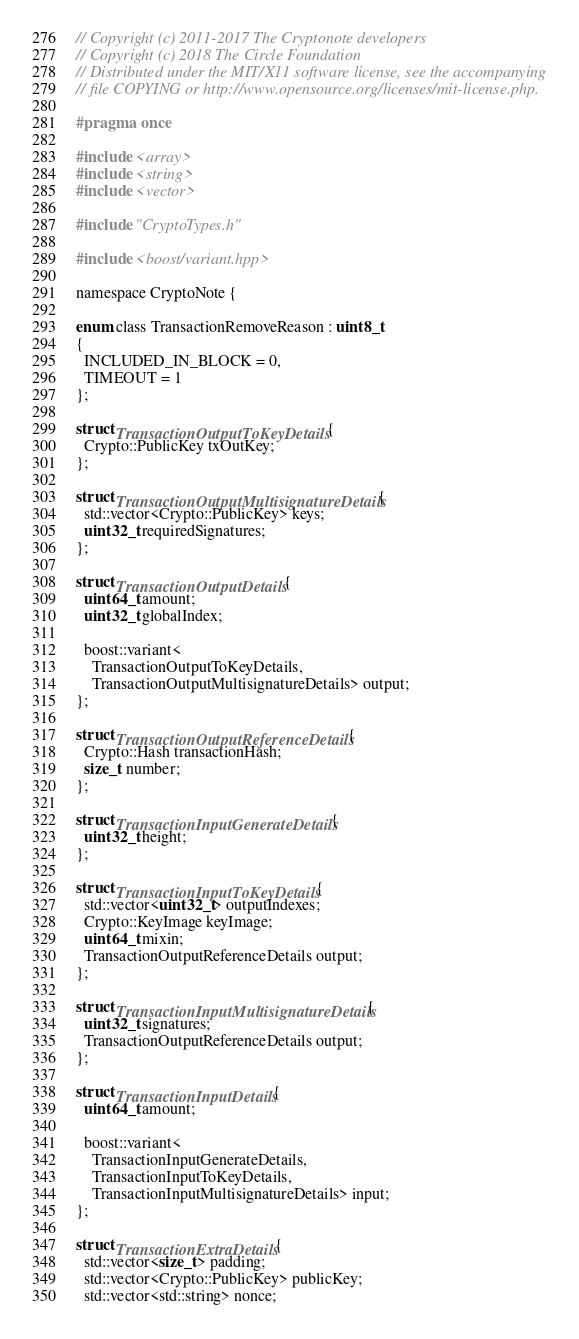<code> <loc_0><loc_0><loc_500><loc_500><_C_>// Copyright (c) 2011-2017 The Cryptonote developers
// Copyright (c) 2018 The Circle Foundation
// Distributed under the MIT/X11 software license, see the accompanying
// file COPYING or http://www.opensource.org/licenses/mit-license.php.

#pragma once

#include <array>
#include <string>
#include <vector>

#include "CryptoTypes.h"

#include <boost/variant.hpp>

namespace CryptoNote {

enum class TransactionRemoveReason : uint8_t 
{ 
  INCLUDED_IN_BLOCK = 0, 
  TIMEOUT = 1
};

struct TransactionOutputToKeyDetails {
  Crypto::PublicKey txOutKey;
};

struct TransactionOutputMultisignatureDetails {
  std::vector<Crypto::PublicKey> keys;
  uint32_t requiredSignatures;
};

struct TransactionOutputDetails {
  uint64_t amount;
  uint32_t globalIndex;

  boost::variant<
    TransactionOutputToKeyDetails,
    TransactionOutputMultisignatureDetails> output;
};

struct TransactionOutputReferenceDetails {
  Crypto::Hash transactionHash;
  size_t number;
};

struct TransactionInputGenerateDetails {
  uint32_t height;
};

struct TransactionInputToKeyDetails {
  std::vector<uint32_t> outputIndexes;
  Crypto::KeyImage keyImage;
  uint64_t mixin;
  TransactionOutputReferenceDetails output;
};

struct TransactionInputMultisignatureDetails {
  uint32_t signatures;
  TransactionOutputReferenceDetails output;
};

struct TransactionInputDetails {
  uint64_t amount;

  boost::variant<
    TransactionInputGenerateDetails,
    TransactionInputToKeyDetails,
    TransactionInputMultisignatureDetails> input;
};

struct TransactionExtraDetails {
  std::vector<size_t> padding;
  std::vector<Crypto::PublicKey> publicKey; 
  std::vector<std::string> nonce;</code> 